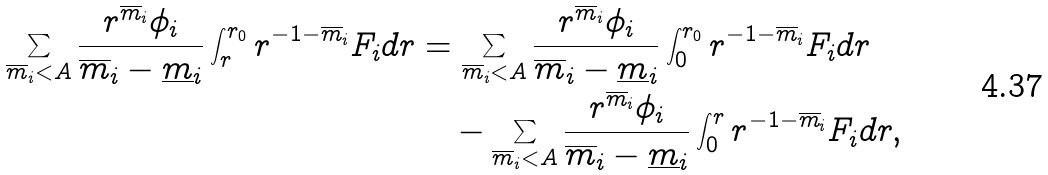Convert formula to latex. <formula><loc_0><loc_0><loc_500><loc_500>\sum _ { \overline { m } _ { i } < A } \frac { r ^ { \overline { m } _ { i } } \phi _ { i } } { \overline { m } _ { i } - \underline { m } _ { i } } \int _ { r } ^ { r _ { 0 } } r ^ { - 1 - \overline { m } _ { i } } F _ { i } d r & = \sum _ { \overline { m } _ { i } < A } \frac { r ^ { \overline { m } _ { i } } \phi _ { i } } { \overline { m } _ { i } - \underline { m } _ { i } } \int _ { 0 } ^ { r _ { 0 } } r ^ { - 1 - \overline { m } _ { i } } F _ { i } d r \\ & \quad - \sum _ { \overline { m } _ { i } < A } \frac { r ^ { \overline { m } _ { i } } \phi _ { i } } { \overline { m } _ { i } - \underline { m } _ { i } } \int _ { 0 } ^ { r } r ^ { - 1 - \overline { m } _ { i } } F _ { i } d r ,</formula> 